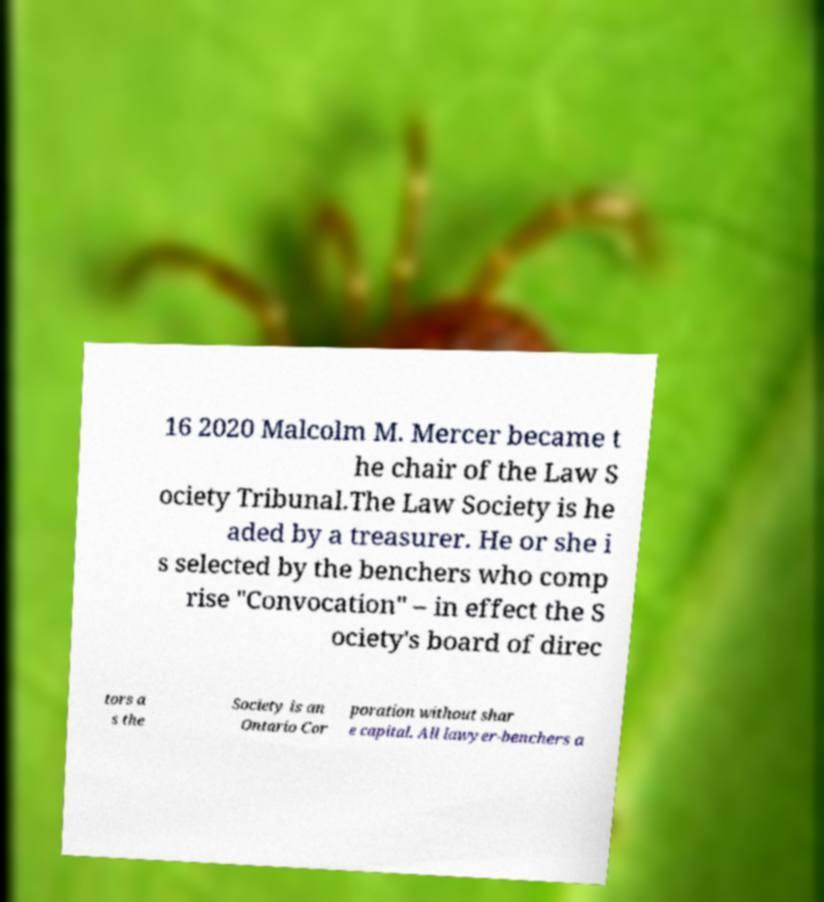There's text embedded in this image that I need extracted. Can you transcribe it verbatim? 16 2020 Malcolm M. Mercer became t he chair of the Law S ociety Tribunal.The Law Society is he aded by a treasurer. He or she i s selected by the benchers who comp rise "Convocation" – in effect the S ociety's board of direc tors a s the Society is an Ontario Cor poration without shar e capital. All lawyer-benchers a 